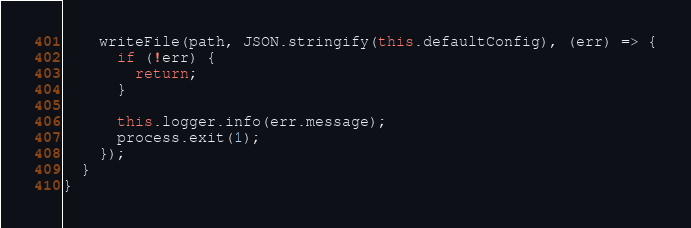Convert code to text. <code><loc_0><loc_0><loc_500><loc_500><_TypeScript_>    writeFile(path, JSON.stringify(this.defaultConfig), (err) => {
      if (!err) {
        return;
      }

      this.logger.info(err.message);
      process.exit(1);
    });
  }
}
</code> 